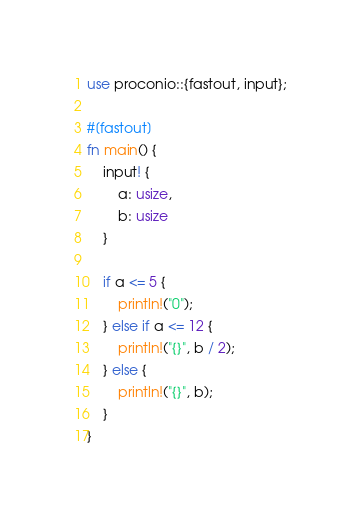Convert code to text. <code><loc_0><loc_0><loc_500><loc_500><_Rust_>use proconio::{fastout, input};

#[fastout]
fn main() {
    input! {
        a: usize,
        b: usize
    }

    if a <= 5 {
        println!("0");
    } else if a <= 12 {
        println!("{}", b / 2);
    } else {
        println!("{}", b);
    }
}</code> 